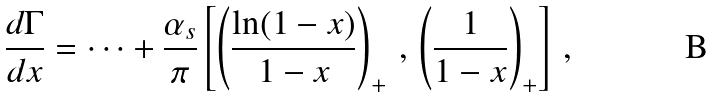<formula> <loc_0><loc_0><loc_500><loc_500>\frac { d \Gamma } { d x } = \cdots + \frac { \alpha _ { s } } { \pi } \left [ \left ( \frac { \ln ( 1 - x ) } { 1 - x } \right ) _ { + } \, , \, \left ( \frac { 1 } { 1 - x } \right ) _ { + } \right ] \, ,</formula> 